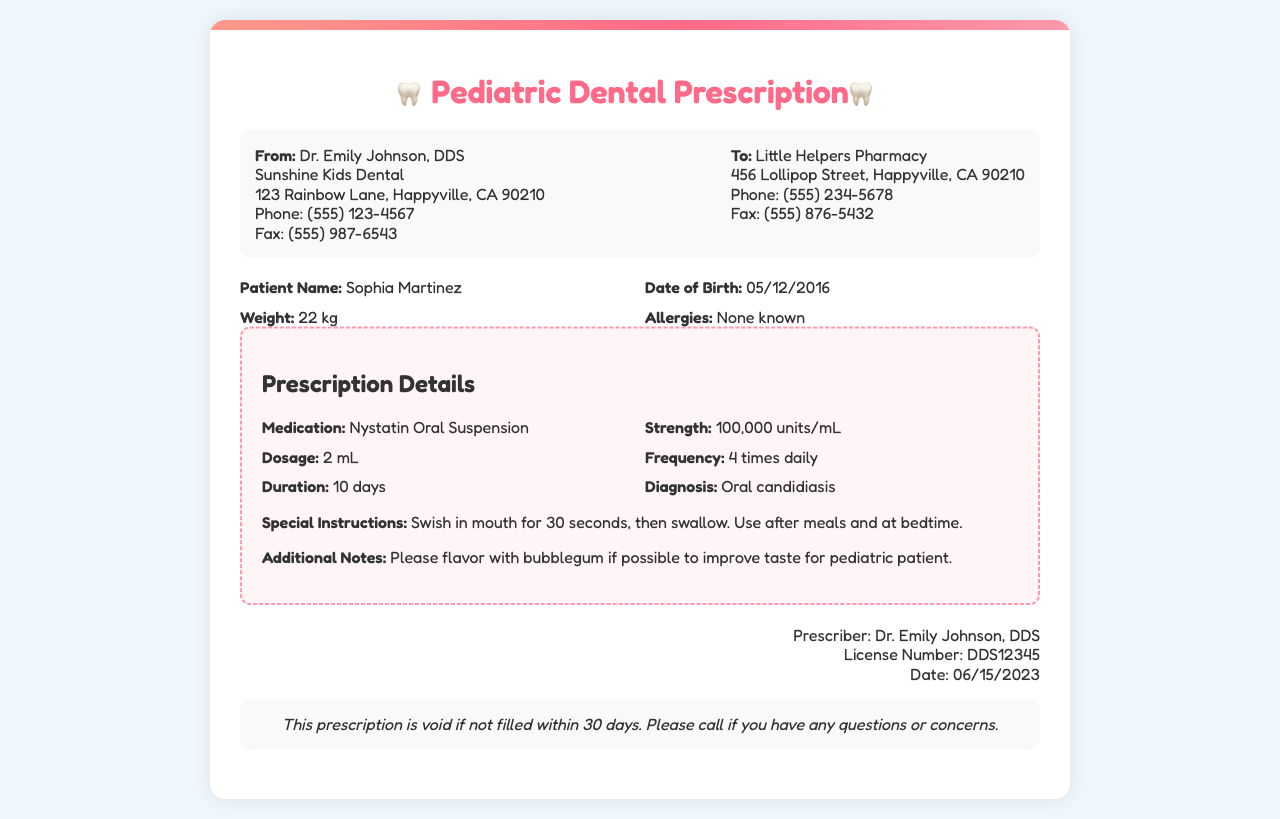What is the patient's name? The patient's name is stated clearly in the document under patient information.
Answer: Sophia Martinez What medication is prescribed? The prescribed medication is specified in the prescription details section of the document.
Answer: Nystatin Oral Suspension What is the strength of the medication? The strength of the medication is given in the prescription details.
Answer: 100,000 units/mL How often should the medication be administered? The frequency of administration is noted in the prescription details section.
Answer: 4 times daily What is the duration for taking the medication? The duration for which the medication should be taken is mentioned in the document.
Answer: 10 days What special instruction is provided for the medication? The special instructions for administering the medication are included in the prescription section.
Answer: Swish in mouth for 30 seconds, then swallow Who is the prescriber? The prescriber’s name is listed at the bottom of the document under the signature section.
Answer: Dr. Emily Johnson What is the date on the prescription? The date of the prescription is indicated in the signature section of the document.
Answer: 06/15/2023 What allergy does the patient have? The patient's allergies are described in the patient information section.
Answer: None known 